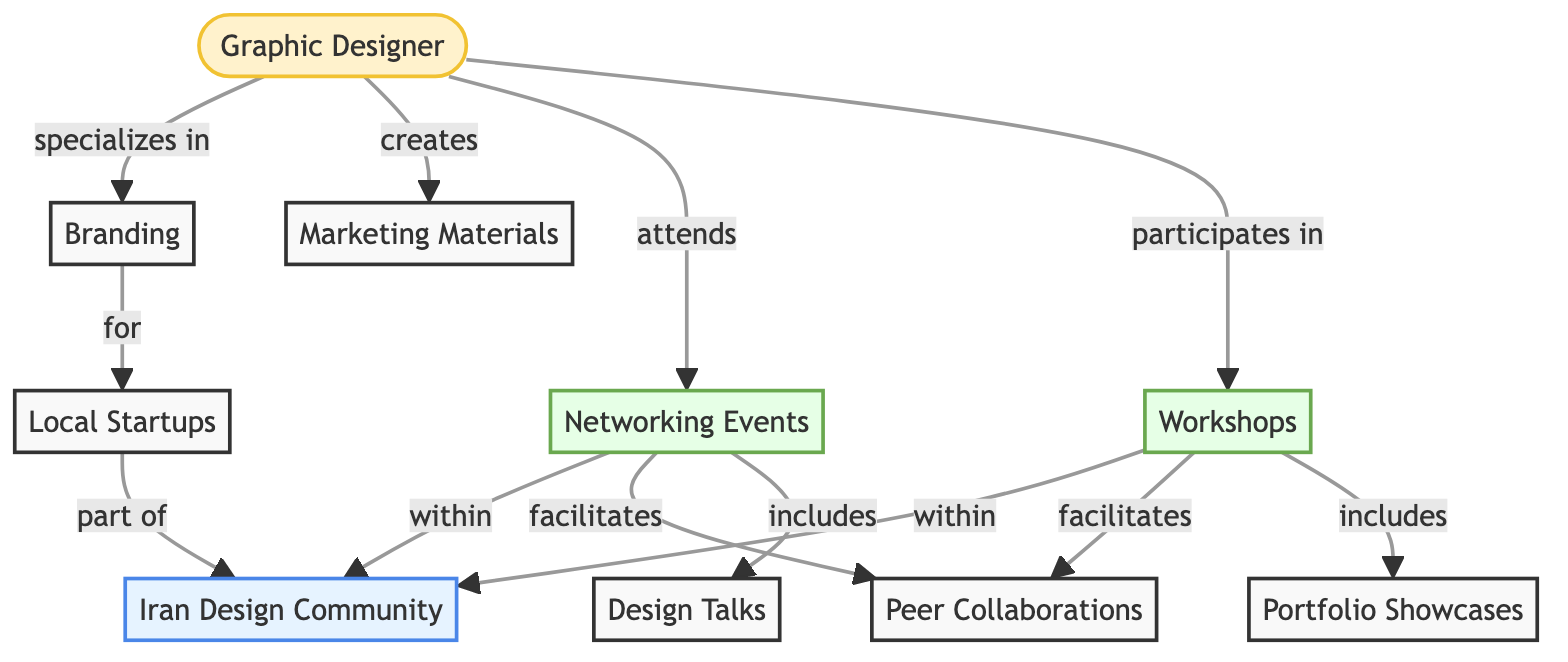What type of professional is represented in the diagram? The diagram prominently features a node labeled "Graphic Designer," indicating that this is the professional type represented.
Answer: Graphic Designer How many nodes are present in the diagram? By counting all the unique labeled nodes in the diagram, we find there are 10 distinct nodes listed.
Answer: 10 What are the two activities that the designer participates in? The diagram shows that the designer engages in two activities, specifically "Networking Events" and "Workshops."
Answer: Networking Events and Workshops Which node does "Branding" connect to as its target? The "Branding" node has an outgoing edge labeled "for" pointing to the "Local Startups" node. This indicates the target relationship originating from Branding.
Answer: Local Startups What does "Networking Events" facilitate according to the diagram? The diagram indicates that "Networking Events" facilitates "Peer Collaborations," as shown by the directed edge leading to this node.
Answer: Peer Collaborations Who are the beneficiaries of the designer’s creations? The designer's creations are directed towards "Marketing Materials," indicating these are the outputs intended for use by local entities.
Answer: Marketing Materials Which event includes "Design Talks"? The connection from "Networking Events" indicates that it includes "Design Talks," as shown by the directed edge specified in the diagram.
Answer: Design Talks What are the two local startup activities mentioned in the diagram? The diagram indicates that "Local Startups" are part of the "Iran Design Community" and benefit from "Branding"; these are the two activities related to local startups.
Answer: Iran Design Community and Branding How do "Workshops" influence "Portfolio Showcases"? "Workshops" have a directed connection to "Portfolio Showcases," identified in the diagram as an included activity, indicating that workshops directly support showcases.
Answer: Portfolio Showcases What is the hierarchical relationship within the Iran Design Community illustrated here? The diagram shows that both "Networking Events" and "Workshops" operate within the "Iran Design Community," emphasizing a collective structure where activities unify under the community.
Answer: Iran Design Community 